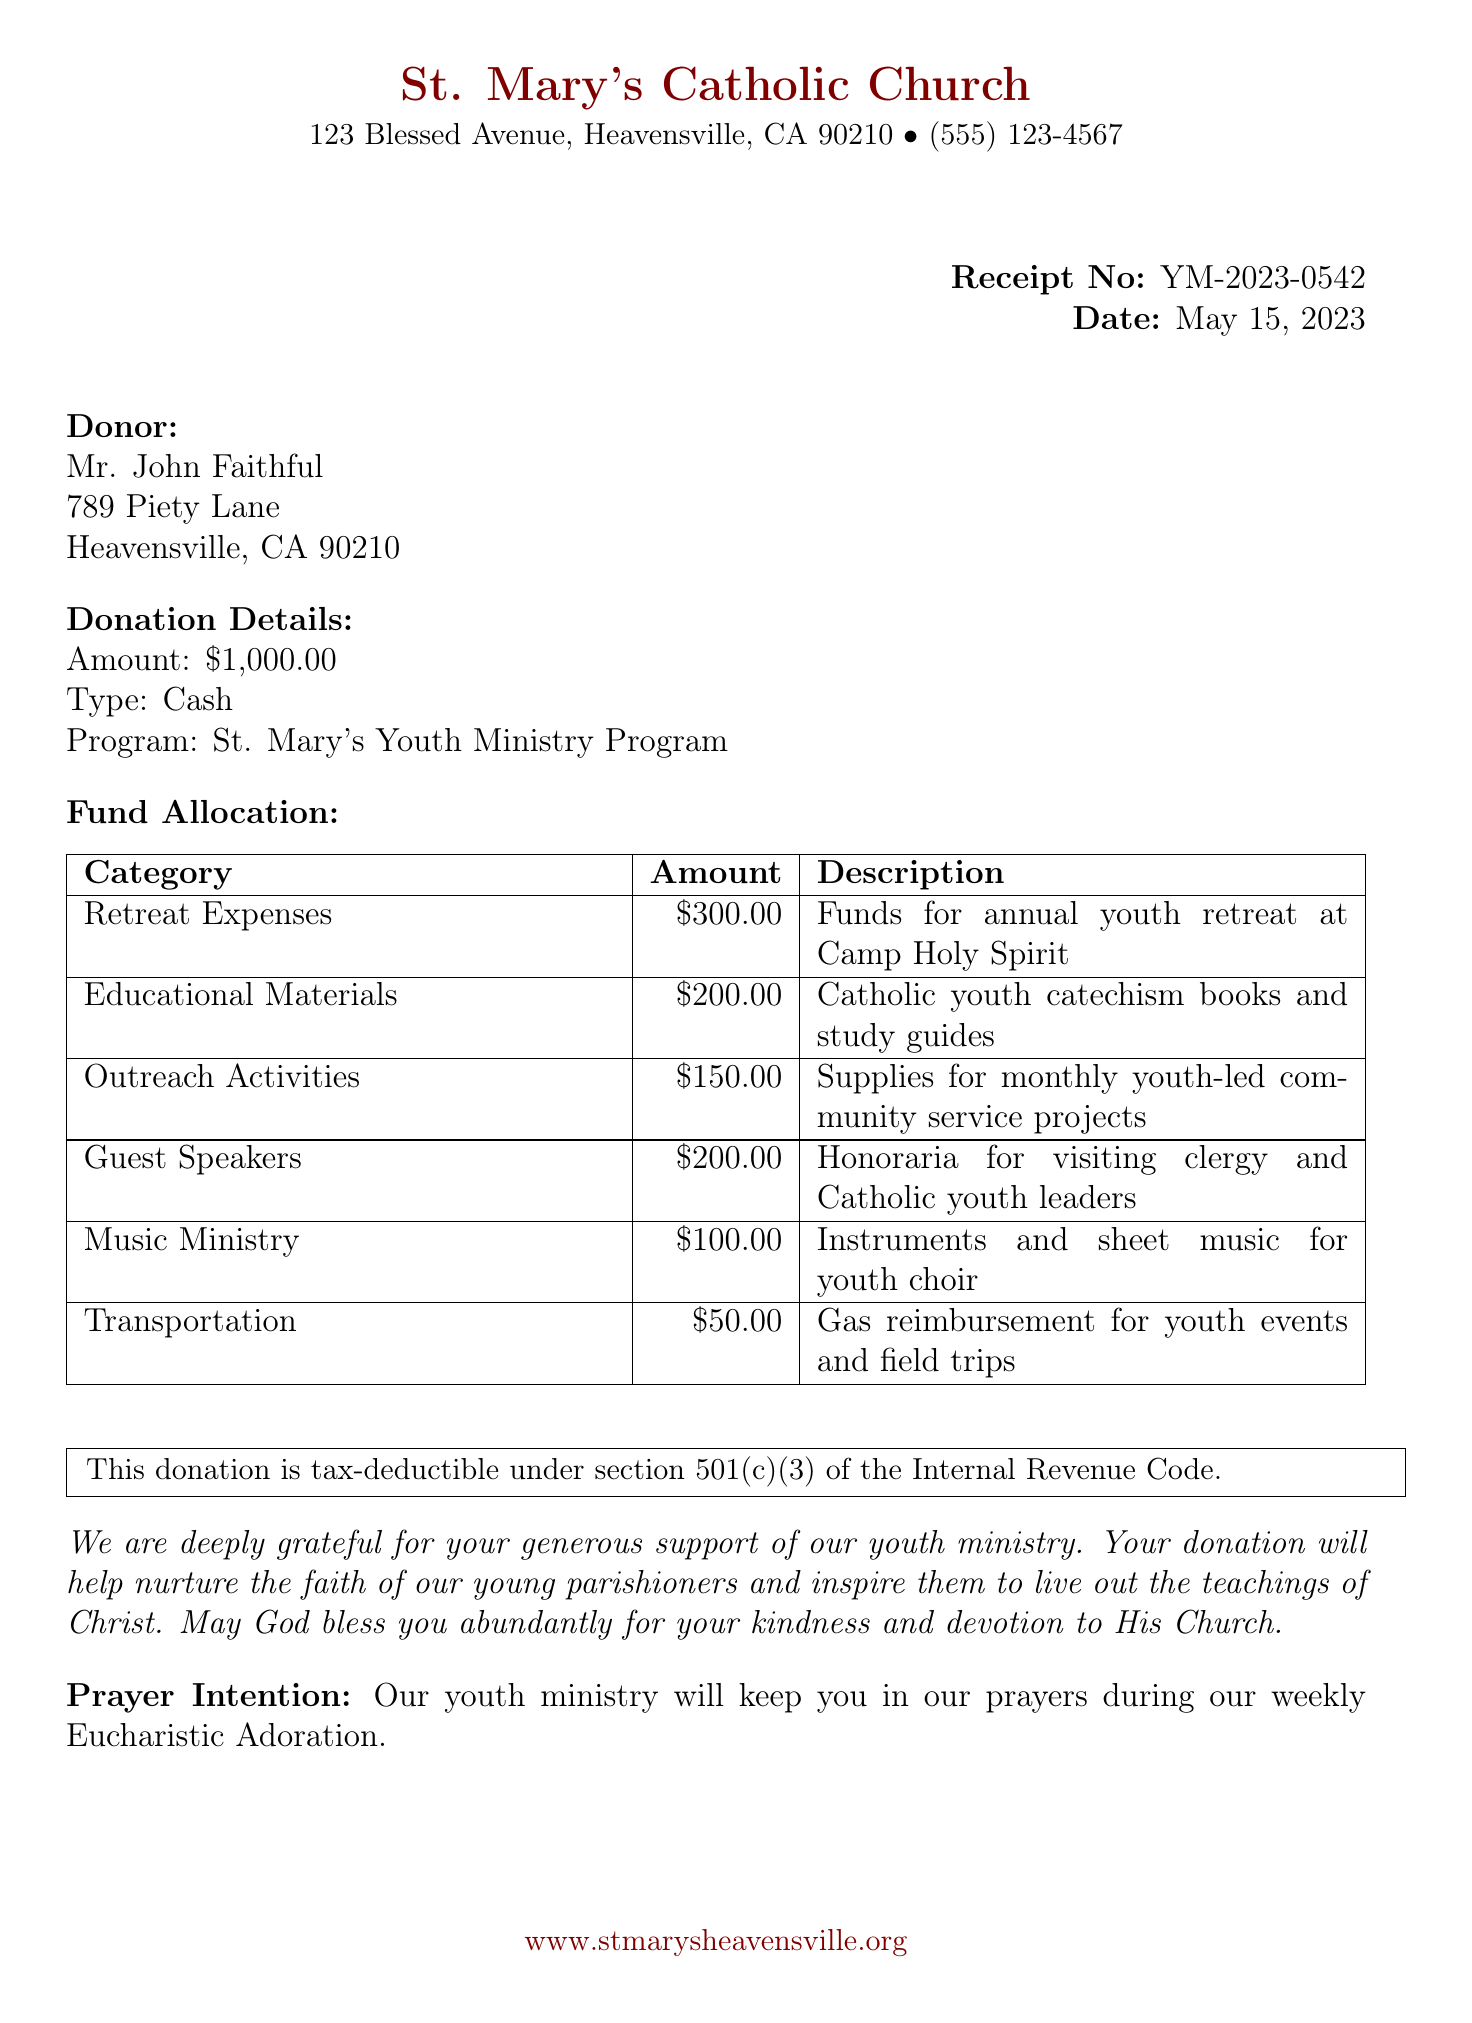What is the parish name? The parish name is clearly stated at the top of the document.
Answer: St. Mary's Catholic Church What is the donation amount? The donation amount is specified under the donation details section.
Answer: $1,000.00 Who signed the receipt? The signature at the bottom indicates who signed the receipt.
Answer: Fr. Michael Blessing How much is allocated for guest speakers? The specific amount for guest speakers is listed in the fund allocation table.
Answer: $200.00 What is the purpose of the educational materials category? The description in the fund allocation explains the purpose of this category.
Answer: Catholic youth catechism books and study guides How will the donation impact the community? The gratitude message expresses how the donation contributes to the community's faith.
Answer: Nurture the faith of our young parishioners When was the donation receipt issued? The date is provided near the receipt number on the document.
Answer: May 15, 2023 What is the tax-deductible status of this donation? The tax-deductible statement is included in the document.
Answer: This donation is tax-deductible under section 501(c)(3) Who is the youth minister? The name of the youth minister is listed at the end of the document.
Answer: Sister Maria Grace 